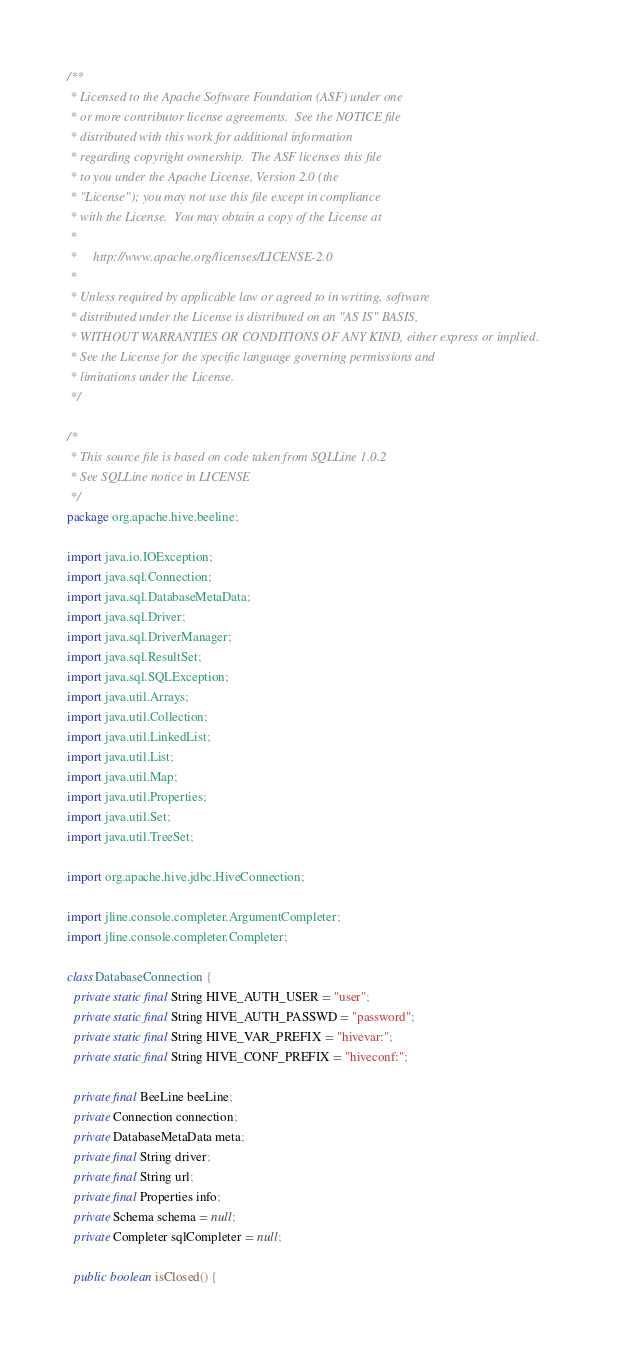<code> <loc_0><loc_0><loc_500><loc_500><_Java_>/**
 * Licensed to the Apache Software Foundation (ASF) under one
 * or more contributor license agreements.  See the NOTICE file
 * distributed with this work for additional information
 * regarding copyright ownership.  The ASF licenses this file
 * to you under the Apache License, Version 2.0 (the
 * "License"); you may not use this file except in compliance
 * with the License.  You may obtain a copy of the License at
 *
 *     http://www.apache.org/licenses/LICENSE-2.0
 *
 * Unless required by applicable law or agreed to in writing, software
 * distributed under the License is distributed on an "AS IS" BASIS,
 * WITHOUT WARRANTIES OR CONDITIONS OF ANY KIND, either express or implied.
 * See the License for the specific language governing permissions and
 * limitations under the License.
 */

/*
 * This source file is based on code taken from SQLLine 1.0.2
 * See SQLLine notice in LICENSE
 */
package org.apache.hive.beeline;

import java.io.IOException;
import java.sql.Connection;
import java.sql.DatabaseMetaData;
import java.sql.Driver;
import java.sql.DriverManager;
import java.sql.ResultSet;
import java.sql.SQLException;
import java.util.Arrays;
import java.util.Collection;
import java.util.LinkedList;
import java.util.List;
import java.util.Map;
import java.util.Properties;
import java.util.Set;
import java.util.TreeSet;

import org.apache.hive.jdbc.HiveConnection;

import jline.console.completer.ArgumentCompleter;
import jline.console.completer.Completer;

class DatabaseConnection {
  private static final String HIVE_AUTH_USER = "user";
  private static final String HIVE_AUTH_PASSWD = "password";
  private static final String HIVE_VAR_PREFIX = "hivevar:";
  private static final String HIVE_CONF_PREFIX = "hiveconf:";

  private final BeeLine beeLine;
  private Connection connection;
  private DatabaseMetaData meta;
  private final String driver;
  private final String url;
  private final Properties info;
  private Schema schema = null;
  private Completer sqlCompleter = null;

  public boolean isClosed() {</code> 